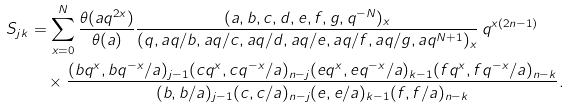Convert formula to latex. <formula><loc_0><loc_0><loc_500><loc_500>S _ { j k } & = \sum _ { x = 0 } ^ { N } \frac { \theta ( a q ^ { 2 x } ) } { \theta ( a ) } \frac { ( a , b , c , d , e , f , g , q ^ { - N } ) _ { x } } { ( q , a q / b , a q / c , a q / d , a q / e , a q / f , a q / g , a q ^ { N + 1 } ) _ { x } } \, q ^ { x ( 2 n - 1 ) } \\ & \quad \times \frac { ( b q ^ { x } , b q ^ { - x } / a ) _ { j - 1 } ( c q ^ { x } , c q ^ { - x } / a ) _ { n - j } ( e q ^ { x } , e q ^ { - x } / a ) _ { k - 1 } ( f q ^ { x } , f q ^ { - x } / a ) _ { n - k } } { ( b , b / a ) _ { j - 1 } ( c , c / a ) _ { n - j } ( e , e / a ) _ { k - 1 } ( f , f / a ) _ { n - k } } .</formula> 